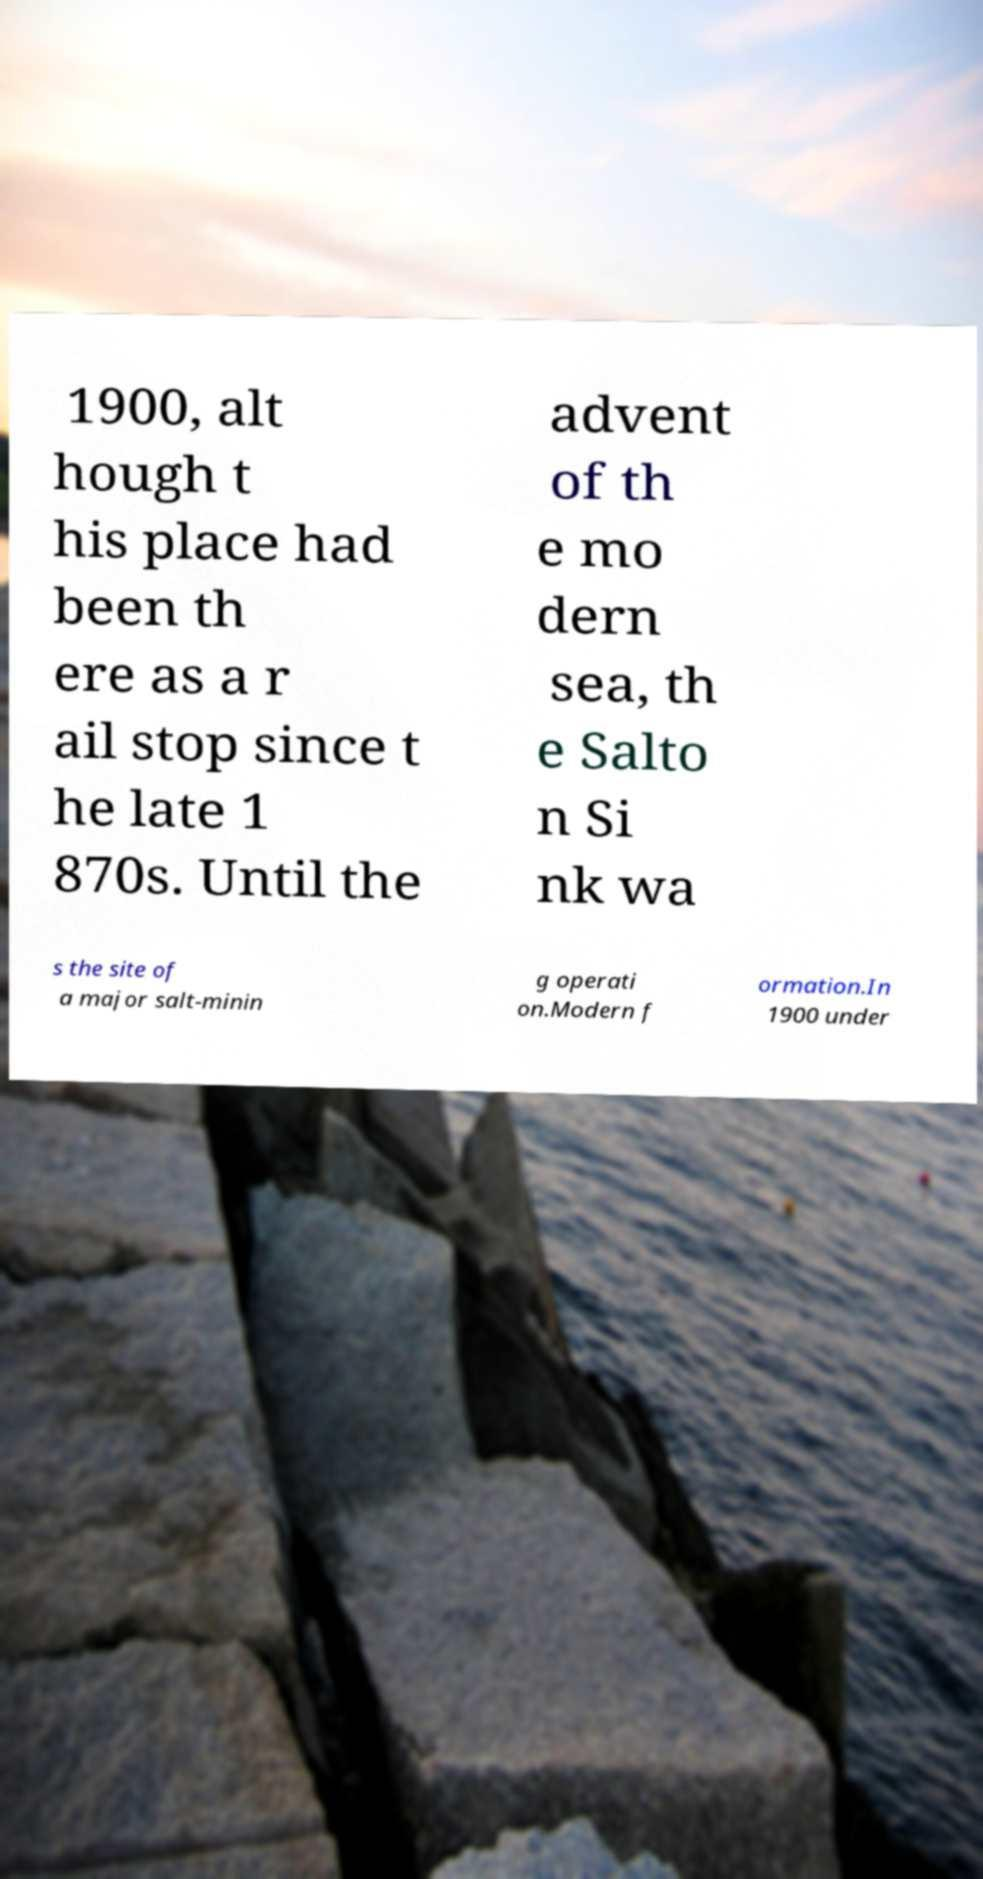Could you assist in decoding the text presented in this image and type it out clearly? 1900, alt hough t his place had been th ere as a r ail stop since t he late 1 870s. Until the advent of th e mo dern sea, th e Salto n Si nk wa s the site of a major salt-minin g operati on.Modern f ormation.In 1900 under 